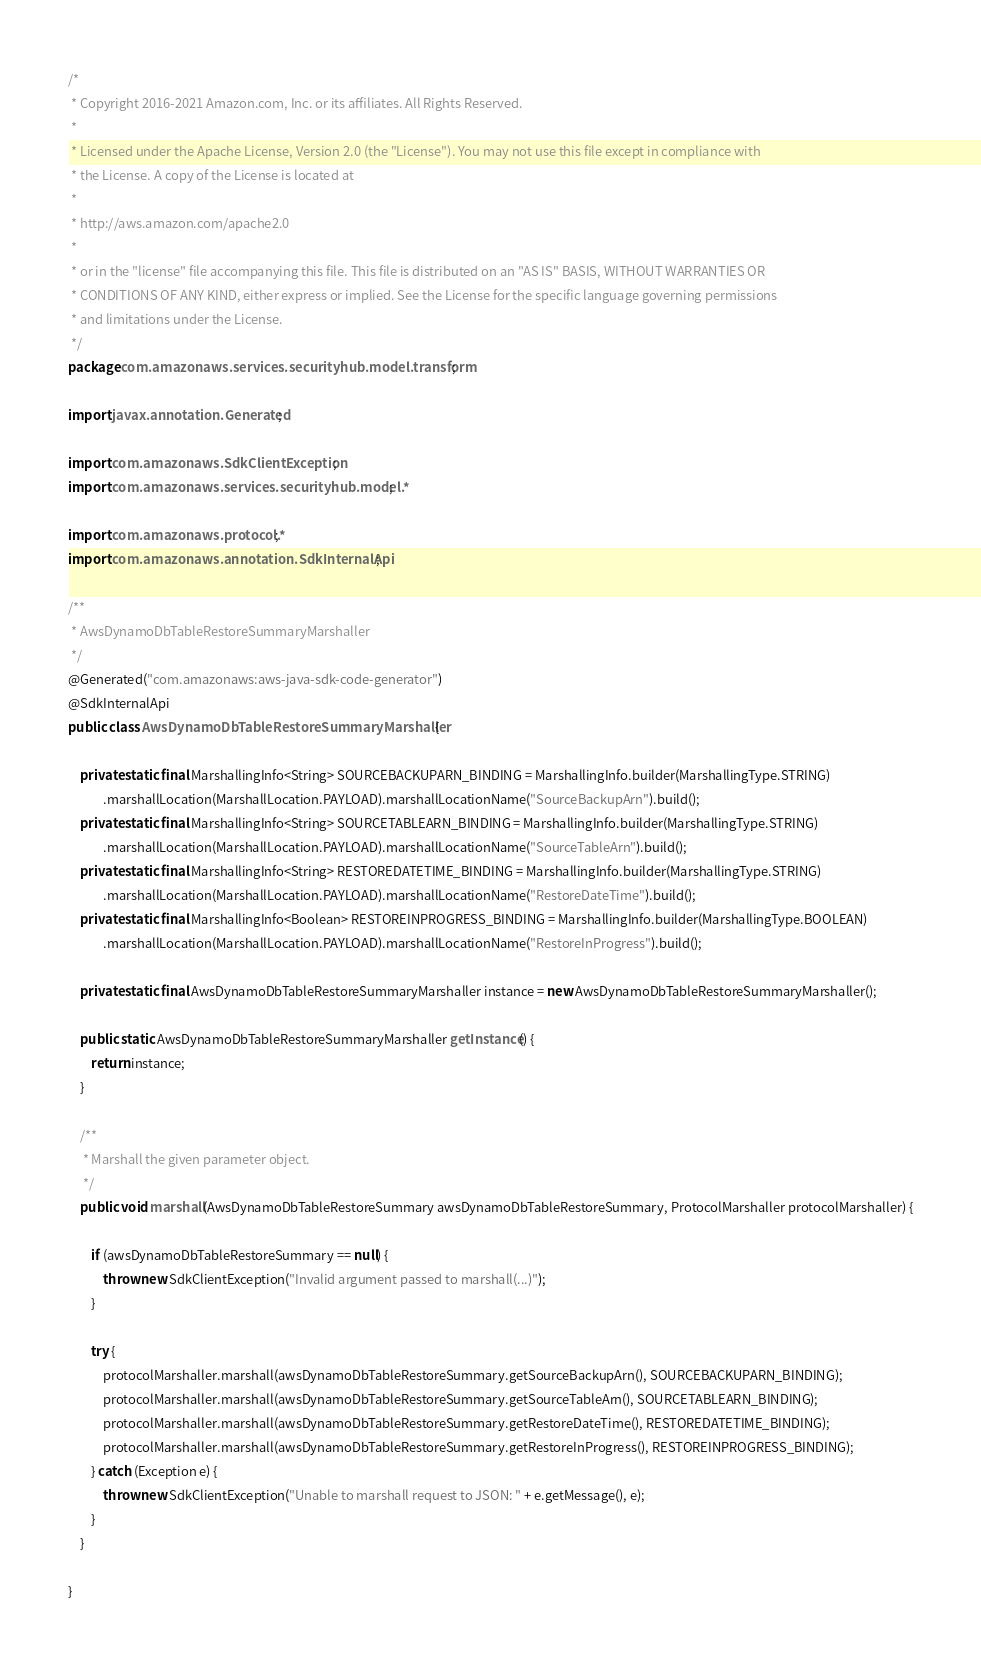<code> <loc_0><loc_0><loc_500><loc_500><_Java_>/*
 * Copyright 2016-2021 Amazon.com, Inc. or its affiliates. All Rights Reserved.
 * 
 * Licensed under the Apache License, Version 2.0 (the "License"). You may not use this file except in compliance with
 * the License. A copy of the License is located at
 * 
 * http://aws.amazon.com/apache2.0
 * 
 * or in the "license" file accompanying this file. This file is distributed on an "AS IS" BASIS, WITHOUT WARRANTIES OR
 * CONDITIONS OF ANY KIND, either express or implied. See the License for the specific language governing permissions
 * and limitations under the License.
 */
package com.amazonaws.services.securityhub.model.transform;

import javax.annotation.Generated;

import com.amazonaws.SdkClientException;
import com.amazonaws.services.securityhub.model.*;

import com.amazonaws.protocol.*;
import com.amazonaws.annotation.SdkInternalApi;

/**
 * AwsDynamoDbTableRestoreSummaryMarshaller
 */
@Generated("com.amazonaws:aws-java-sdk-code-generator")
@SdkInternalApi
public class AwsDynamoDbTableRestoreSummaryMarshaller {

    private static final MarshallingInfo<String> SOURCEBACKUPARN_BINDING = MarshallingInfo.builder(MarshallingType.STRING)
            .marshallLocation(MarshallLocation.PAYLOAD).marshallLocationName("SourceBackupArn").build();
    private static final MarshallingInfo<String> SOURCETABLEARN_BINDING = MarshallingInfo.builder(MarshallingType.STRING)
            .marshallLocation(MarshallLocation.PAYLOAD).marshallLocationName("SourceTableArn").build();
    private static final MarshallingInfo<String> RESTOREDATETIME_BINDING = MarshallingInfo.builder(MarshallingType.STRING)
            .marshallLocation(MarshallLocation.PAYLOAD).marshallLocationName("RestoreDateTime").build();
    private static final MarshallingInfo<Boolean> RESTOREINPROGRESS_BINDING = MarshallingInfo.builder(MarshallingType.BOOLEAN)
            .marshallLocation(MarshallLocation.PAYLOAD).marshallLocationName("RestoreInProgress").build();

    private static final AwsDynamoDbTableRestoreSummaryMarshaller instance = new AwsDynamoDbTableRestoreSummaryMarshaller();

    public static AwsDynamoDbTableRestoreSummaryMarshaller getInstance() {
        return instance;
    }

    /**
     * Marshall the given parameter object.
     */
    public void marshall(AwsDynamoDbTableRestoreSummary awsDynamoDbTableRestoreSummary, ProtocolMarshaller protocolMarshaller) {

        if (awsDynamoDbTableRestoreSummary == null) {
            throw new SdkClientException("Invalid argument passed to marshall(...)");
        }

        try {
            protocolMarshaller.marshall(awsDynamoDbTableRestoreSummary.getSourceBackupArn(), SOURCEBACKUPARN_BINDING);
            protocolMarshaller.marshall(awsDynamoDbTableRestoreSummary.getSourceTableArn(), SOURCETABLEARN_BINDING);
            protocolMarshaller.marshall(awsDynamoDbTableRestoreSummary.getRestoreDateTime(), RESTOREDATETIME_BINDING);
            protocolMarshaller.marshall(awsDynamoDbTableRestoreSummary.getRestoreInProgress(), RESTOREINPROGRESS_BINDING);
        } catch (Exception e) {
            throw new SdkClientException("Unable to marshall request to JSON: " + e.getMessage(), e);
        }
    }

}
</code> 